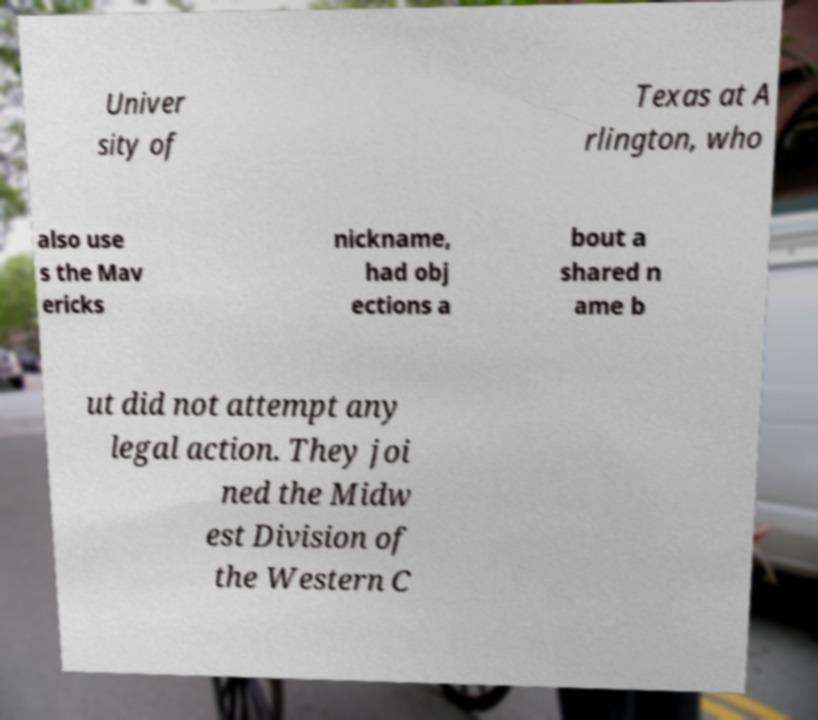Please identify and transcribe the text found in this image. Univer sity of Texas at A rlington, who also use s the Mav ericks nickname, had obj ections a bout a shared n ame b ut did not attempt any legal action. They joi ned the Midw est Division of the Western C 